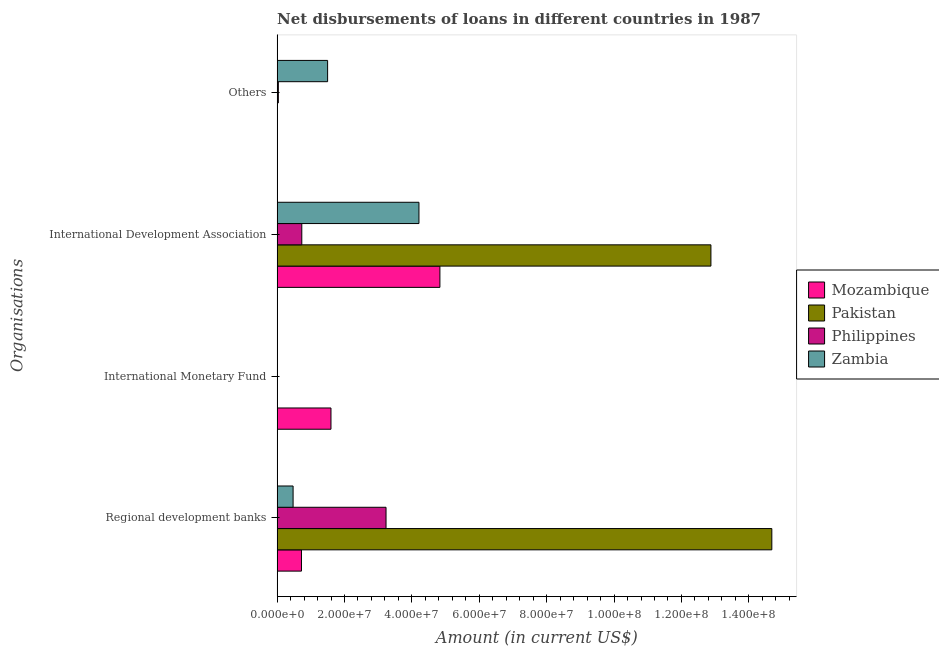Are the number of bars on each tick of the Y-axis equal?
Your answer should be very brief. No. How many bars are there on the 3rd tick from the top?
Provide a succinct answer. 1. How many bars are there on the 2nd tick from the bottom?
Provide a succinct answer. 1. What is the label of the 3rd group of bars from the top?
Offer a terse response. International Monetary Fund. What is the amount of loan disimbursed by international monetary fund in Philippines?
Your answer should be compact. 0. Across all countries, what is the maximum amount of loan disimbursed by other organisations?
Give a very brief answer. 1.50e+07. Across all countries, what is the minimum amount of loan disimbursed by regional development banks?
Keep it short and to the point. 4.74e+06. In which country was the amount of loan disimbursed by international monetary fund maximum?
Your answer should be very brief. Mozambique. What is the total amount of loan disimbursed by international monetary fund in the graph?
Give a very brief answer. 1.60e+07. What is the difference between the amount of loan disimbursed by regional development banks in Philippines and that in Zambia?
Your answer should be compact. 2.76e+07. What is the difference between the amount of loan disimbursed by regional development banks in Zambia and the amount of loan disimbursed by other organisations in Philippines?
Ensure brevity in your answer.  4.38e+06. What is the average amount of loan disimbursed by other organisations per country?
Your answer should be very brief. 3.84e+06. What is the difference between the amount of loan disimbursed by other organisations and amount of loan disimbursed by international development association in Philippines?
Give a very brief answer. -6.96e+06. In how many countries, is the amount of loan disimbursed by regional development banks greater than 80000000 US$?
Provide a succinct answer. 1. What is the ratio of the amount of loan disimbursed by regional development banks in Pakistan to that in Philippines?
Offer a very short reply. 4.54. What is the difference between the highest and the second highest amount of loan disimbursed by regional development banks?
Give a very brief answer. 1.15e+08. What is the difference between the highest and the lowest amount of loan disimbursed by international development association?
Provide a succinct answer. 1.21e+08. How many bars are there?
Give a very brief answer. 11. Are all the bars in the graph horizontal?
Make the answer very short. Yes. How many countries are there in the graph?
Your answer should be very brief. 4. What is the difference between two consecutive major ticks on the X-axis?
Your answer should be compact. 2.00e+07. Are the values on the major ticks of X-axis written in scientific E-notation?
Provide a succinct answer. Yes. How many legend labels are there?
Offer a terse response. 4. What is the title of the graph?
Offer a very short reply. Net disbursements of loans in different countries in 1987. Does "Timor-Leste" appear as one of the legend labels in the graph?
Provide a succinct answer. No. What is the label or title of the Y-axis?
Keep it short and to the point. Organisations. What is the Amount (in current US$) of Mozambique in Regional development banks?
Your answer should be compact. 7.23e+06. What is the Amount (in current US$) of Pakistan in Regional development banks?
Give a very brief answer. 1.47e+08. What is the Amount (in current US$) in Philippines in Regional development banks?
Your answer should be compact. 3.23e+07. What is the Amount (in current US$) of Zambia in Regional development banks?
Give a very brief answer. 4.74e+06. What is the Amount (in current US$) of Mozambique in International Monetary Fund?
Your answer should be very brief. 1.60e+07. What is the Amount (in current US$) of Pakistan in International Monetary Fund?
Your answer should be compact. 0. What is the Amount (in current US$) in Zambia in International Monetary Fund?
Your answer should be very brief. 0. What is the Amount (in current US$) in Mozambique in International Development Association?
Your response must be concise. 4.83e+07. What is the Amount (in current US$) in Pakistan in International Development Association?
Make the answer very short. 1.29e+08. What is the Amount (in current US$) of Philippines in International Development Association?
Give a very brief answer. 7.32e+06. What is the Amount (in current US$) in Zambia in International Development Association?
Provide a short and direct response. 4.21e+07. What is the Amount (in current US$) of Mozambique in Others?
Give a very brief answer. 0. What is the Amount (in current US$) of Philippines in Others?
Provide a succinct answer. 3.63e+05. What is the Amount (in current US$) of Zambia in Others?
Keep it short and to the point. 1.50e+07. Across all Organisations, what is the maximum Amount (in current US$) in Mozambique?
Your answer should be very brief. 4.83e+07. Across all Organisations, what is the maximum Amount (in current US$) in Pakistan?
Keep it short and to the point. 1.47e+08. Across all Organisations, what is the maximum Amount (in current US$) of Philippines?
Provide a short and direct response. 3.23e+07. Across all Organisations, what is the maximum Amount (in current US$) in Zambia?
Give a very brief answer. 4.21e+07. Across all Organisations, what is the minimum Amount (in current US$) in Mozambique?
Provide a short and direct response. 0. Across all Organisations, what is the minimum Amount (in current US$) in Zambia?
Keep it short and to the point. 0. What is the total Amount (in current US$) in Mozambique in the graph?
Offer a terse response. 7.15e+07. What is the total Amount (in current US$) in Pakistan in the graph?
Offer a very short reply. 2.76e+08. What is the total Amount (in current US$) of Philippines in the graph?
Ensure brevity in your answer.  4.00e+07. What is the total Amount (in current US$) of Zambia in the graph?
Your answer should be compact. 6.18e+07. What is the difference between the Amount (in current US$) of Mozambique in Regional development banks and that in International Monetary Fund?
Offer a very short reply. -8.75e+06. What is the difference between the Amount (in current US$) of Mozambique in Regional development banks and that in International Development Association?
Your answer should be very brief. -4.11e+07. What is the difference between the Amount (in current US$) of Pakistan in Regional development banks and that in International Development Association?
Offer a terse response. 1.81e+07. What is the difference between the Amount (in current US$) in Philippines in Regional development banks and that in International Development Association?
Make the answer very short. 2.50e+07. What is the difference between the Amount (in current US$) of Zambia in Regional development banks and that in International Development Association?
Provide a short and direct response. -3.74e+07. What is the difference between the Amount (in current US$) in Philippines in Regional development banks and that in Others?
Offer a very short reply. 3.20e+07. What is the difference between the Amount (in current US$) of Zambia in Regional development banks and that in Others?
Your answer should be compact. -1.02e+07. What is the difference between the Amount (in current US$) in Mozambique in International Monetary Fund and that in International Development Association?
Provide a short and direct response. -3.23e+07. What is the difference between the Amount (in current US$) of Philippines in International Development Association and that in Others?
Make the answer very short. 6.96e+06. What is the difference between the Amount (in current US$) in Zambia in International Development Association and that in Others?
Offer a very short reply. 2.71e+07. What is the difference between the Amount (in current US$) of Mozambique in Regional development banks and the Amount (in current US$) of Pakistan in International Development Association?
Give a very brief answer. -1.22e+08. What is the difference between the Amount (in current US$) in Mozambique in Regional development banks and the Amount (in current US$) in Philippines in International Development Association?
Offer a terse response. -9.70e+04. What is the difference between the Amount (in current US$) of Mozambique in Regional development banks and the Amount (in current US$) of Zambia in International Development Association?
Your answer should be compact. -3.49e+07. What is the difference between the Amount (in current US$) in Pakistan in Regional development banks and the Amount (in current US$) in Philippines in International Development Association?
Your answer should be compact. 1.40e+08. What is the difference between the Amount (in current US$) in Pakistan in Regional development banks and the Amount (in current US$) in Zambia in International Development Association?
Your response must be concise. 1.05e+08. What is the difference between the Amount (in current US$) of Philippines in Regional development banks and the Amount (in current US$) of Zambia in International Development Association?
Offer a very short reply. -9.77e+06. What is the difference between the Amount (in current US$) in Mozambique in Regional development banks and the Amount (in current US$) in Philippines in Others?
Ensure brevity in your answer.  6.86e+06. What is the difference between the Amount (in current US$) of Mozambique in Regional development banks and the Amount (in current US$) of Zambia in Others?
Ensure brevity in your answer.  -7.76e+06. What is the difference between the Amount (in current US$) of Pakistan in Regional development banks and the Amount (in current US$) of Philippines in Others?
Give a very brief answer. 1.46e+08. What is the difference between the Amount (in current US$) in Pakistan in Regional development banks and the Amount (in current US$) in Zambia in Others?
Your answer should be compact. 1.32e+08. What is the difference between the Amount (in current US$) of Philippines in Regional development banks and the Amount (in current US$) of Zambia in Others?
Your answer should be very brief. 1.73e+07. What is the difference between the Amount (in current US$) in Mozambique in International Monetary Fund and the Amount (in current US$) in Pakistan in International Development Association?
Your response must be concise. -1.13e+08. What is the difference between the Amount (in current US$) in Mozambique in International Monetary Fund and the Amount (in current US$) in Philippines in International Development Association?
Provide a succinct answer. 8.66e+06. What is the difference between the Amount (in current US$) in Mozambique in International Monetary Fund and the Amount (in current US$) in Zambia in International Development Association?
Provide a short and direct response. -2.61e+07. What is the difference between the Amount (in current US$) of Mozambique in International Monetary Fund and the Amount (in current US$) of Philippines in Others?
Your response must be concise. 1.56e+07. What is the difference between the Amount (in current US$) of Mozambique in International Monetary Fund and the Amount (in current US$) of Zambia in Others?
Offer a very short reply. 9.97e+05. What is the difference between the Amount (in current US$) of Mozambique in International Development Association and the Amount (in current US$) of Philippines in Others?
Make the answer very short. 4.80e+07. What is the difference between the Amount (in current US$) in Mozambique in International Development Association and the Amount (in current US$) in Zambia in Others?
Your answer should be compact. 3.33e+07. What is the difference between the Amount (in current US$) in Pakistan in International Development Association and the Amount (in current US$) in Philippines in Others?
Your answer should be very brief. 1.28e+08. What is the difference between the Amount (in current US$) in Pakistan in International Development Association and the Amount (in current US$) in Zambia in Others?
Provide a succinct answer. 1.14e+08. What is the difference between the Amount (in current US$) of Philippines in International Development Association and the Amount (in current US$) of Zambia in Others?
Ensure brevity in your answer.  -7.66e+06. What is the average Amount (in current US$) in Mozambique per Organisations?
Your answer should be compact. 1.79e+07. What is the average Amount (in current US$) in Pakistan per Organisations?
Provide a succinct answer. 6.89e+07. What is the average Amount (in current US$) in Philippines per Organisations?
Provide a succinct answer. 1.00e+07. What is the average Amount (in current US$) of Zambia per Organisations?
Your response must be concise. 1.55e+07. What is the difference between the Amount (in current US$) of Mozambique and Amount (in current US$) of Pakistan in Regional development banks?
Your answer should be very brief. -1.40e+08. What is the difference between the Amount (in current US$) of Mozambique and Amount (in current US$) of Philippines in Regional development banks?
Make the answer very short. -2.51e+07. What is the difference between the Amount (in current US$) of Mozambique and Amount (in current US$) of Zambia in Regional development banks?
Offer a terse response. 2.49e+06. What is the difference between the Amount (in current US$) in Pakistan and Amount (in current US$) in Philippines in Regional development banks?
Your answer should be very brief. 1.15e+08. What is the difference between the Amount (in current US$) in Pakistan and Amount (in current US$) in Zambia in Regional development banks?
Your answer should be compact. 1.42e+08. What is the difference between the Amount (in current US$) of Philippines and Amount (in current US$) of Zambia in Regional development banks?
Provide a succinct answer. 2.76e+07. What is the difference between the Amount (in current US$) of Mozambique and Amount (in current US$) of Pakistan in International Development Association?
Your response must be concise. -8.04e+07. What is the difference between the Amount (in current US$) in Mozambique and Amount (in current US$) in Philippines in International Development Association?
Ensure brevity in your answer.  4.10e+07. What is the difference between the Amount (in current US$) of Mozambique and Amount (in current US$) of Zambia in International Development Association?
Your response must be concise. 6.22e+06. What is the difference between the Amount (in current US$) of Pakistan and Amount (in current US$) of Philippines in International Development Association?
Your answer should be compact. 1.21e+08. What is the difference between the Amount (in current US$) of Pakistan and Amount (in current US$) of Zambia in International Development Association?
Your answer should be very brief. 8.67e+07. What is the difference between the Amount (in current US$) of Philippines and Amount (in current US$) of Zambia in International Development Association?
Offer a terse response. -3.48e+07. What is the difference between the Amount (in current US$) in Philippines and Amount (in current US$) in Zambia in Others?
Your answer should be compact. -1.46e+07. What is the ratio of the Amount (in current US$) in Mozambique in Regional development banks to that in International Monetary Fund?
Provide a short and direct response. 0.45. What is the ratio of the Amount (in current US$) in Mozambique in Regional development banks to that in International Development Association?
Ensure brevity in your answer.  0.15. What is the ratio of the Amount (in current US$) in Pakistan in Regional development banks to that in International Development Association?
Provide a short and direct response. 1.14. What is the ratio of the Amount (in current US$) in Philippines in Regional development banks to that in International Development Association?
Your answer should be very brief. 4.41. What is the ratio of the Amount (in current US$) in Zambia in Regional development banks to that in International Development Association?
Your answer should be very brief. 0.11. What is the ratio of the Amount (in current US$) in Philippines in Regional development banks to that in Others?
Your answer should be compact. 89.05. What is the ratio of the Amount (in current US$) in Zambia in Regional development banks to that in Others?
Provide a short and direct response. 0.32. What is the ratio of the Amount (in current US$) in Mozambique in International Monetary Fund to that in International Development Association?
Make the answer very short. 0.33. What is the ratio of the Amount (in current US$) of Philippines in International Development Association to that in Others?
Offer a very short reply. 20.18. What is the ratio of the Amount (in current US$) of Zambia in International Development Association to that in Others?
Offer a terse response. 2.81. What is the difference between the highest and the second highest Amount (in current US$) of Mozambique?
Provide a short and direct response. 3.23e+07. What is the difference between the highest and the second highest Amount (in current US$) of Philippines?
Give a very brief answer. 2.50e+07. What is the difference between the highest and the second highest Amount (in current US$) in Zambia?
Provide a succinct answer. 2.71e+07. What is the difference between the highest and the lowest Amount (in current US$) in Mozambique?
Provide a short and direct response. 4.83e+07. What is the difference between the highest and the lowest Amount (in current US$) of Pakistan?
Make the answer very short. 1.47e+08. What is the difference between the highest and the lowest Amount (in current US$) of Philippines?
Your answer should be compact. 3.23e+07. What is the difference between the highest and the lowest Amount (in current US$) of Zambia?
Offer a terse response. 4.21e+07. 